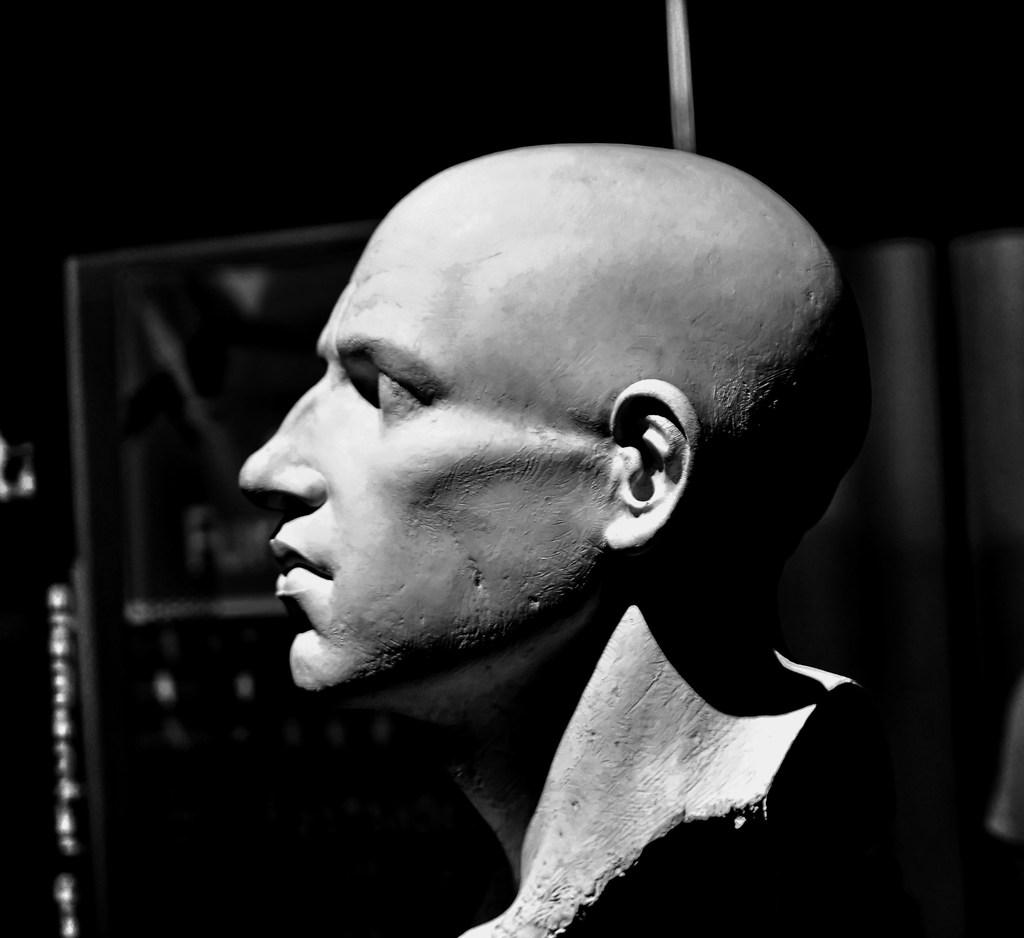What is the color scheme of the image? The image is black and white. What is the main subject of the image? There is a statue of a human in the image. What else can be seen in the background of the image? There appears to be a door in the background of the image. Where is the nest located in the image? There is no nest present in the image. What type of stitch is used to create the statue in the image? The image is black and white, and it is a photograph or drawing, not a sculpture, so there is no stitching involved in creating the statue. 